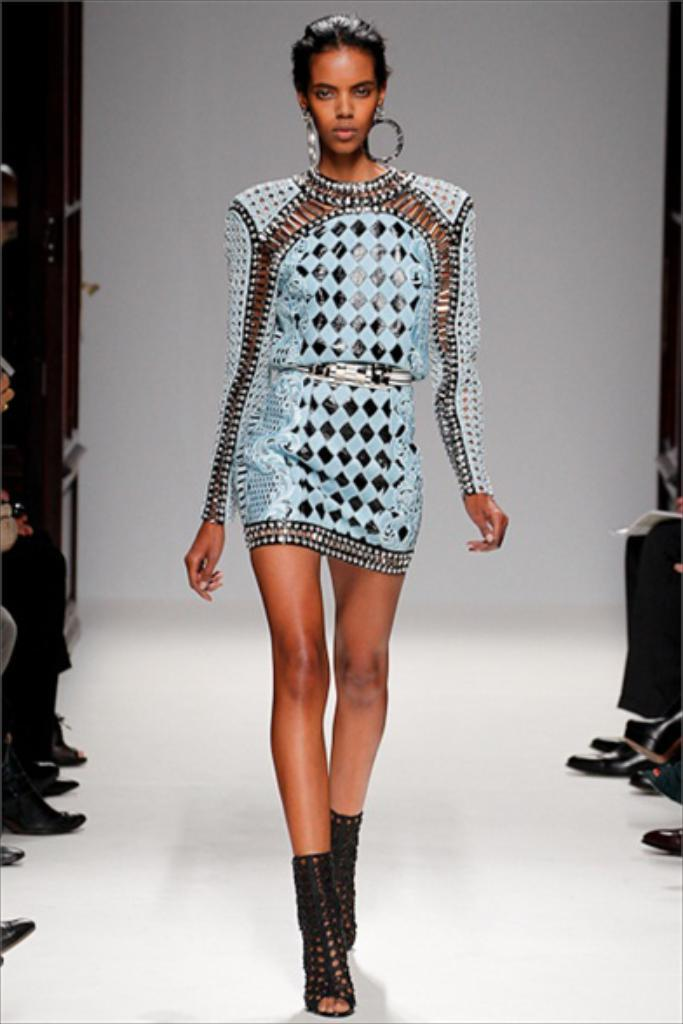What is the woman in the image wearing? The woman is wearing a blue dress in the image. Where is the woman located in the image? The woman is visible on the floor in the image. What else can be seen in the image besides the woman? Person's legs are visible in the image. What is visible on both sides of the image? Boats are visible on the left side and the right side of the image. What type of wave is the woman riding in the image? There is no wave present in the image, and the woman is not riding any wave. 